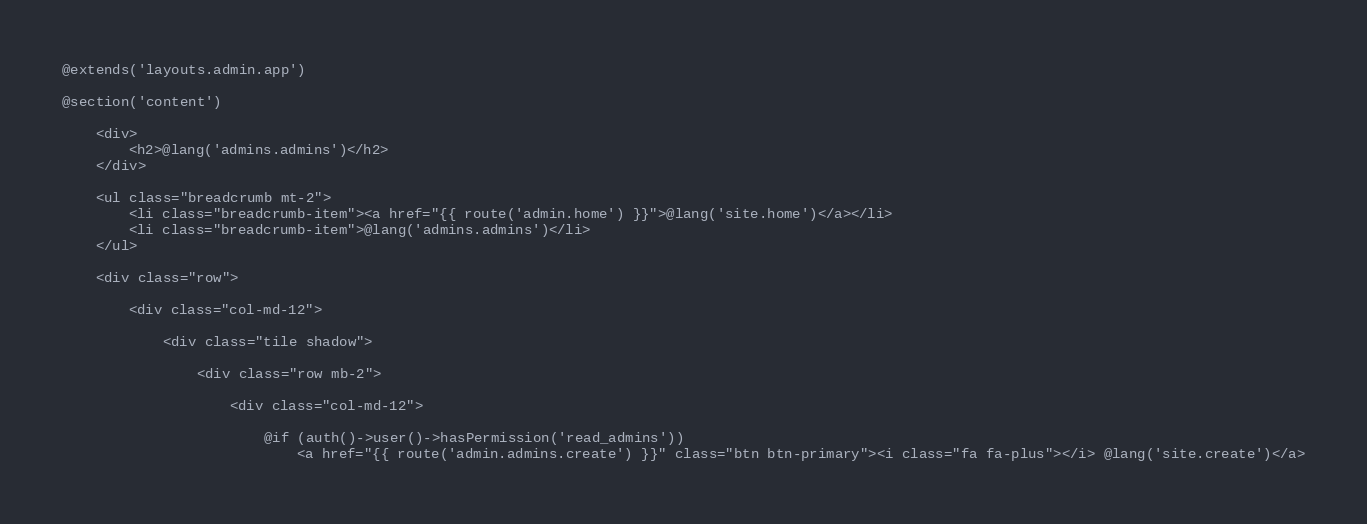<code> <loc_0><loc_0><loc_500><loc_500><_PHP_>@extends('layouts.admin.app')

@section('content')

    <div>
        <h2>@lang('admins.admins')</h2>
    </div>

    <ul class="breadcrumb mt-2">
        <li class="breadcrumb-item"><a href="{{ route('admin.home') }}">@lang('site.home')</a></li>
        <li class="breadcrumb-item">@lang('admins.admins')</li>
    </ul>

    <div class="row">

        <div class="col-md-12">

            <div class="tile shadow">

                <div class="row mb-2">

                    <div class="col-md-12">

                        @if (auth()->user()->hasPermission('read_admins'))
                            <a href="{{ route('admin.admins.create') }}" class="btn btn-primary"><i class="fa fa-plus"></i> @lang('site.create')</a></code> 